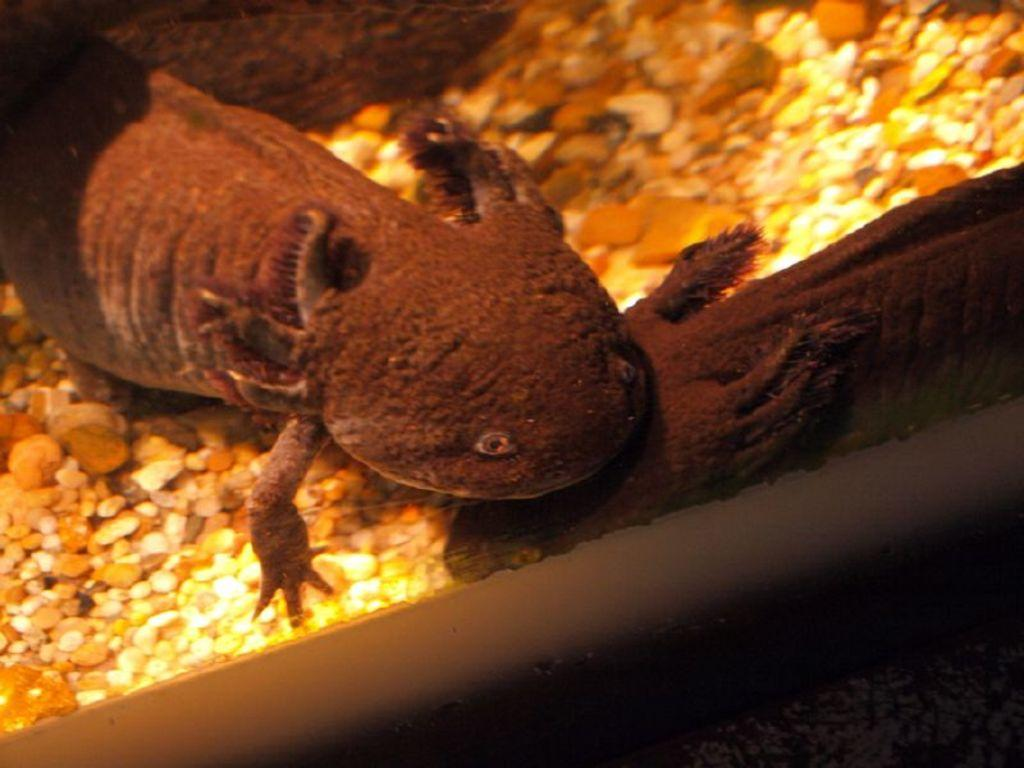What type of animal is in the image? There is a reptile in the image. What is the reptile resting on? The reptile is on some stones. What type of love is expressed by the reptile in the image? There is no indication of love or any emotion in the image; it simply shows a reptile on some stones. 